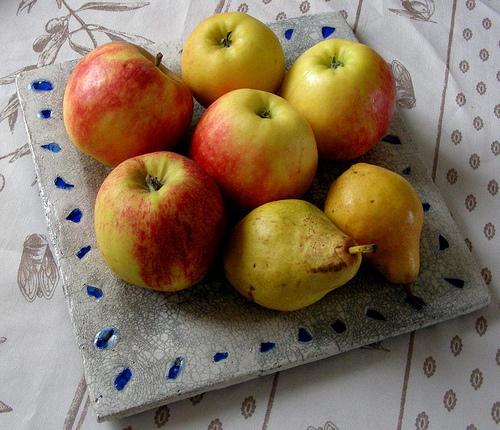What are the blue specks in the plate made of?
Short answer required. Glass. What is the probability that a pear will be randomly selected from this plate?
Write a very short answer. 2/7. What color is the apple?
Give a very brief answer. Red and yellow. Is the tablecloth plain or print?
Concise answer only. Print. 